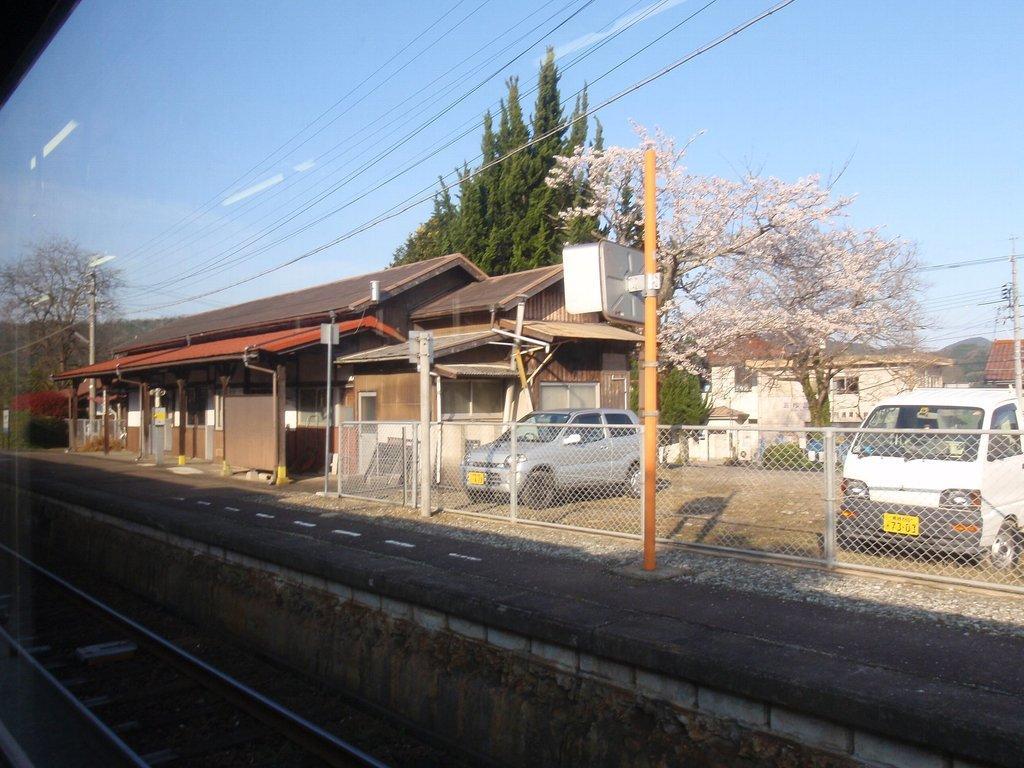Please provide a concise description of this image. In this picture I can see a railway track on the left side, on the right side there are vehicles, trees and a building. In the middle it looks like a wooden house, at the top there is the sky. 